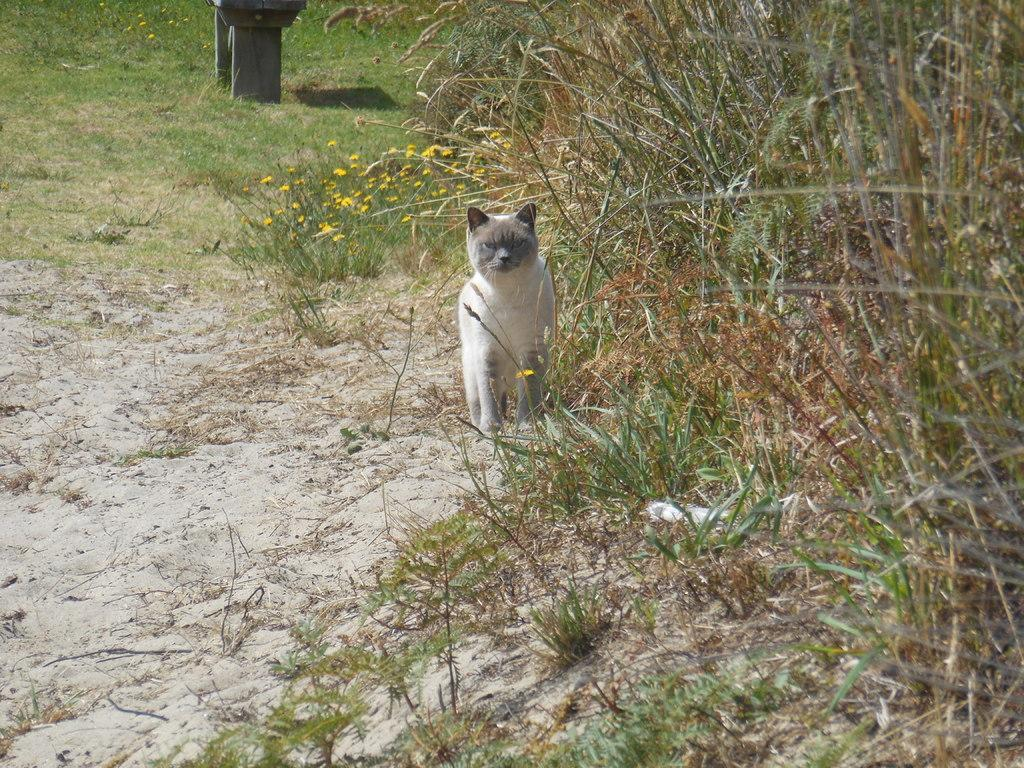What type of animal is in the image? There is an animal in the image, but its specific type cannot be determined from the provided facts. What colors are present on the animal? The animal has white and brown coloring. What can be seen in the background of the image? There are flowers and grass in the background of the image. What color are the flowers? The flowers are yellow in color. What colors are present in the grass? The grass has brown and green coloring. Can you hear the animal's aunt crying in the image? There is no audio component to the image, and therefore it is not possible to hear any sounds, including the animal's aunt crying. 